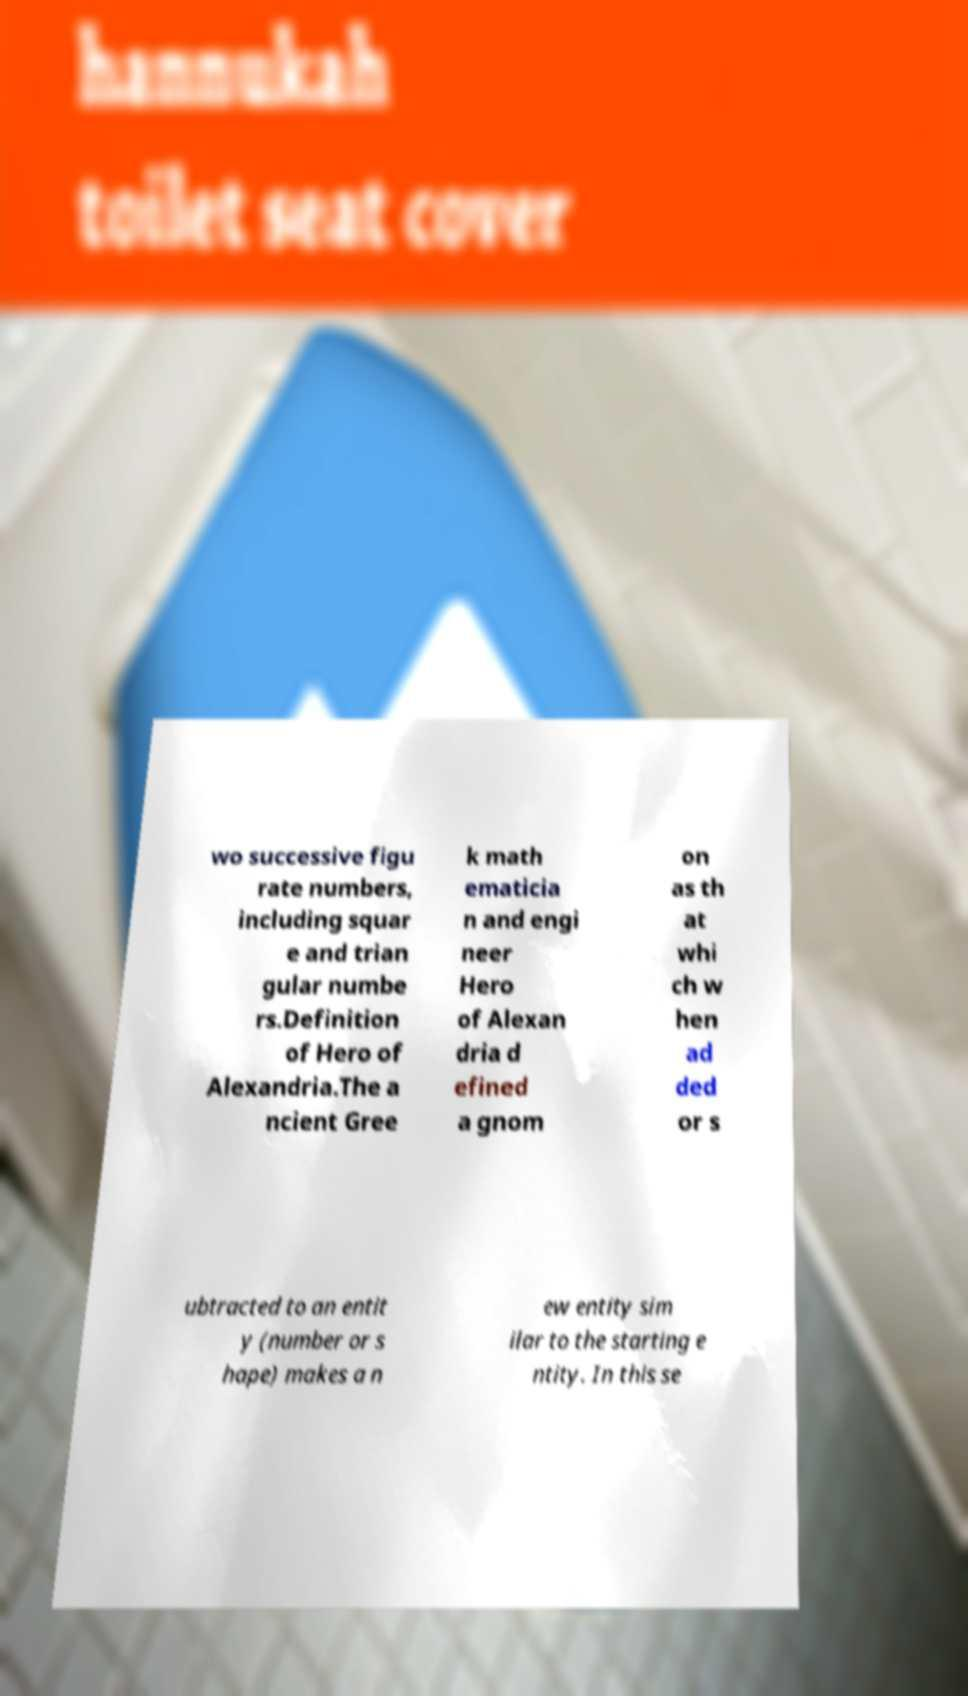Could you assist in decoding the text presented in this image and type it out clearly? wo successive figu rate numbers, including squar e and trian gular numbe rs.Definition of Hero of Alexandria.The a ncient Gree k math ematicia n and engi neer Hero of Alexan dria d efined a gnom on as th at whi ch w hen ad ded or s ubtracted to an entit y (number or s hape) makes a n ew entity sim ilar to the starting e ntity. In this se 